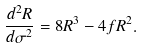Convert formula to latex. <formula><loc_0><loc_0><loc_500><loc_500>\frac { d ^ { 2 } R } { d \sigma ^ { 2 } } = 8 R ^ { 3 } - 4 f R ^ { 2 } .</formula> 